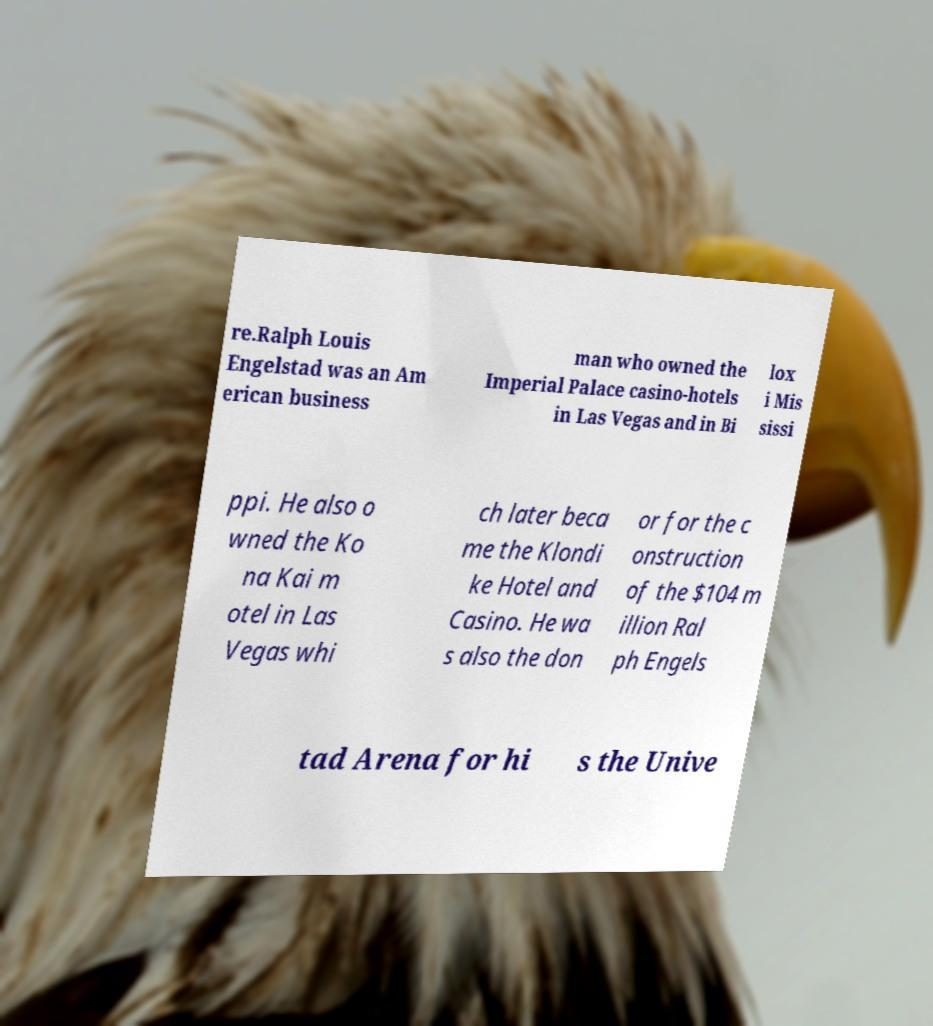Can you read and provide the text displayed in the image?This photo seems to have some interesting text. Can you extract and type it out for me? re.Ralph Louis Engelstad was an Am erican business man who owned the Imperial Palace casino-hotels in Las Vegas and in Bi lox i Mis sissi ppi. He also o wned the Ko na Kai m otel in Las Vegas whi ch later beca me the Klondi ke Hotel and Casino. He wa s also the don or for the c onstruction of the $104 m illion Ral ph Engels tad Arena for hi s the Unive 